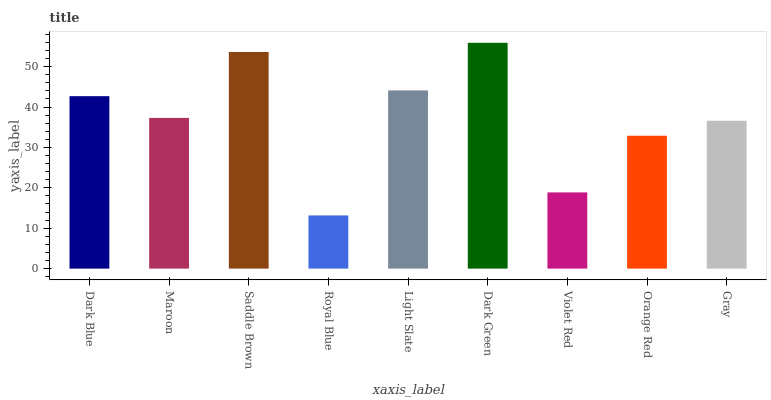Is Royal Blue the minimum?
Answer yes or no. Yes. Is Dark Green the maximum?
Answer yes or no. Yes. Is Maroon the minimum?
Answer yes or no. No. Is Maroon the maximum?
Answer yes or no. No. Is Dark Blue greater than Maroon?
Answer yes or no. Yes. Is Maroon less than Dark Blue?
Answer yes or no. Yes. Is Maroon greater than Dark Blue?
Answer yes or no. No. Is Dark Blue less than Maroon?
Answer yes or no. No. Is Maroon the high median?
Answer yes or no. Yes. Is Maroon the low median?
Answer yes or no. Yes. Is Light Slate the high median?
Answer yes or no. No. Is Dark Green the low median?
Answer yes or no. No. 